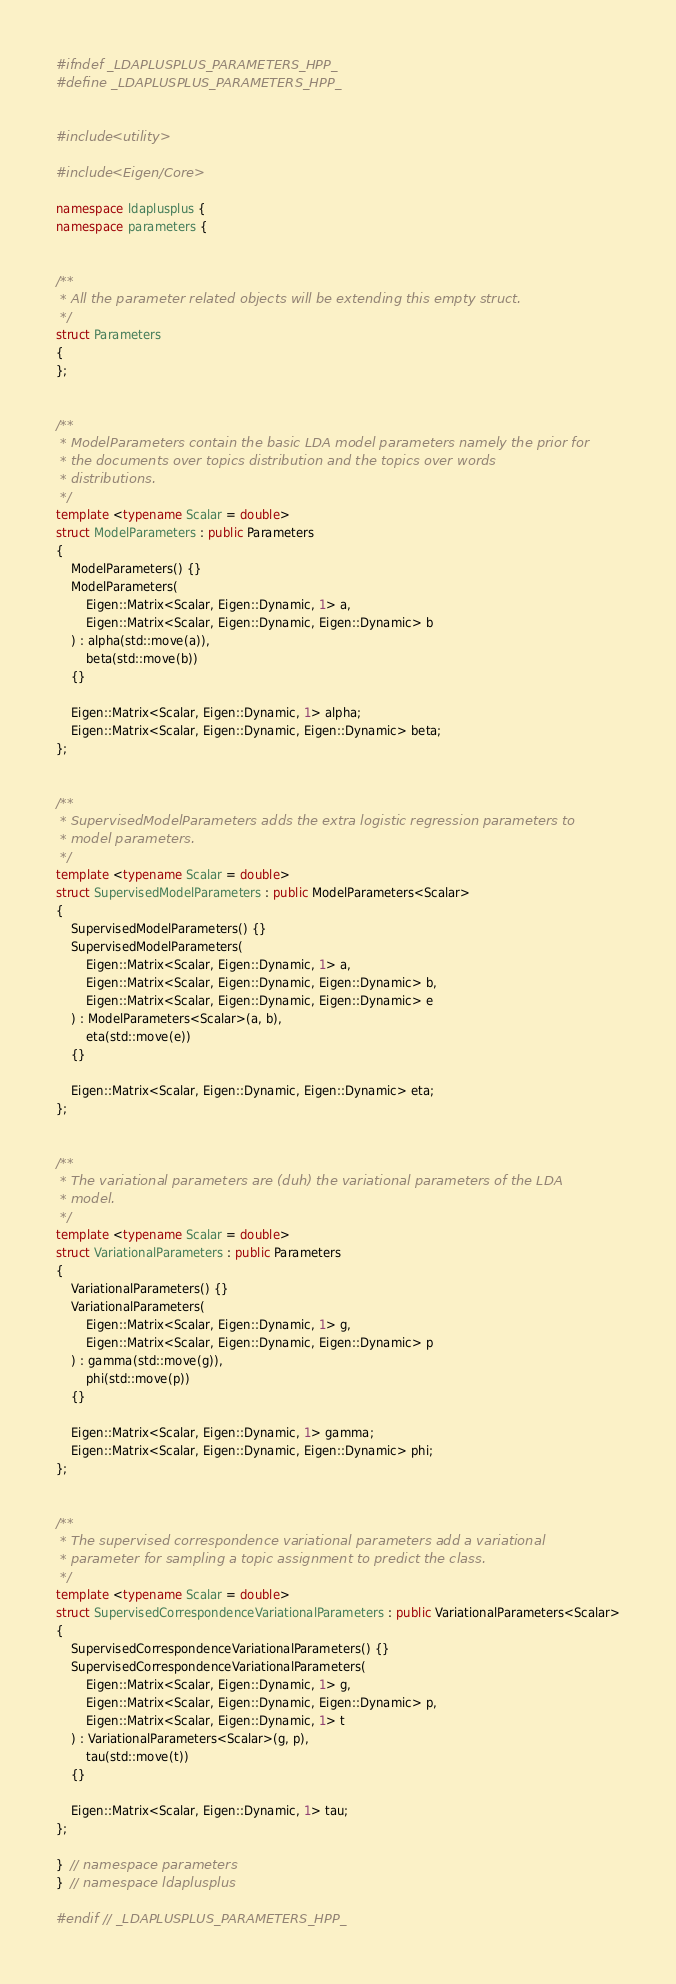Convert code to text. <code><loc_0><loc_0><loc_500><loc_500><_C++_>#ifndef _LDAPLUSPLUS_PARAMETERS_HPP_
#define _LDAPLUSPLUS_PARAMETERS_HPP_


#include <utility>

#include <Eigen/Core>

namespace ldaplusplus {
namespace parameters {


/**
 * All the parameter related objects will be extending this empty struct.
 */
struct Parameters
{
};


/**
 * ModelParameters contain the basic LDA model parameters namely the prior for
 * the documents over topics distribution and the topics over words
 * distributions.
 */
template <typename Scalar = double>
struct ModelParameters : public Parameters
{
    ModelParameters() {}
    ModelParameters(
        Eigen::Matrix<Scalar, Eigen::Dynamic, 1> a,
        Eigen::Matrix<Scalar, Eigen::Dynamic, Eigen::Dynamic> b
    ) : alpha(std::move(a)),
        beta(std::move(b))
    {}

    Eigen::Matrix<Scalar, Eigen::Dynamic, 1> alpha;
    Eigen::Matrix<Scalar, Eigen::Dynamic, Eigen::Dynamic> beta;
};


/**
 * SupervisedModelParameters adds the extra logistic regression parameters to
 * model parameters.
 */
template <typename Scalar = double>
struct SupervisedModelParameters : public ModelParameters<Scalar>
{
    SupervisedModelParameters() {}
    SupervisedModelParameters(
        Eigen::Matrix<Scalar, Eigen::Dynamic, 1> a,
        Eigen::Matrix<Scalar, Eigen::Dynamic, Eigen::Dynamic> b,
        Eigen::Matrix<Scalar, Eigen::Dynamic, Eigen::Dynamic> e
    ) : ModelParameters<Scalar>(a, b),
        eta(std::move(e))
    {}

    Eigen::Matrix<Scalar, Eigen::Dynamic, Eigen::Dynamic> eta;
};


/**
 * The variational parameters are (duh) the variational parameters of the LDA
 * model.
 */
template <typename Scalar = double>
struct VariationalParameters : public Parameters
{
    VariationalParameters() {}
    VariationalParameters(
        Eigen::Matrix<Scalar, Eigen::Dynamic, 1> g,
        Eigen::Matrix<Scalar, Eigen::Dynamic, Eigen::Dynamic> p
    ) : gamma(std::move(g)),
        phi(std::move(p))
    {}

    Eigen::Matrix<Scalar, Eigen::Dynamic, 1> gamma;
    Eigen::Matrix<Scalar, Eigen::Dynamic, Eigen::Dynamic> phi;
};


/**
 * The supervised correspondence variational parameters add a variational
 * parameter for sampling a topic assignment to predict the class.
 */
template <typename Scalar = double>
struct SupervisedCorrespondenceVariationalParameters : public VariationalParameters<Scalar>
{
    SupervisedCorrespondenceVariationalParameters() {}
    SupervisedCorrespondenceVariationalParameters(
        Eigen::Matrix<Scalar, Eigen::Dynamic, 1> g,
        Eigen::Matrix<Scalar, Eigen::Dynamic, Eigen::Dynamic> p,
        Eigen::Matrix<Scalar, Eigen::Dynamic, 1> t
    ) : VariationalParameters<Scalar>(g, p),
        tau(std::move(t))
    {}

    Eigen::Matrix<Scalar, Eigen::Dynamic, 1> tau;
};

}  // namespace parameters
}  // namespace ldaplusplus

#endif  // _LDAPLUSPLUS_PARAMETERS_HPP_
</code> 